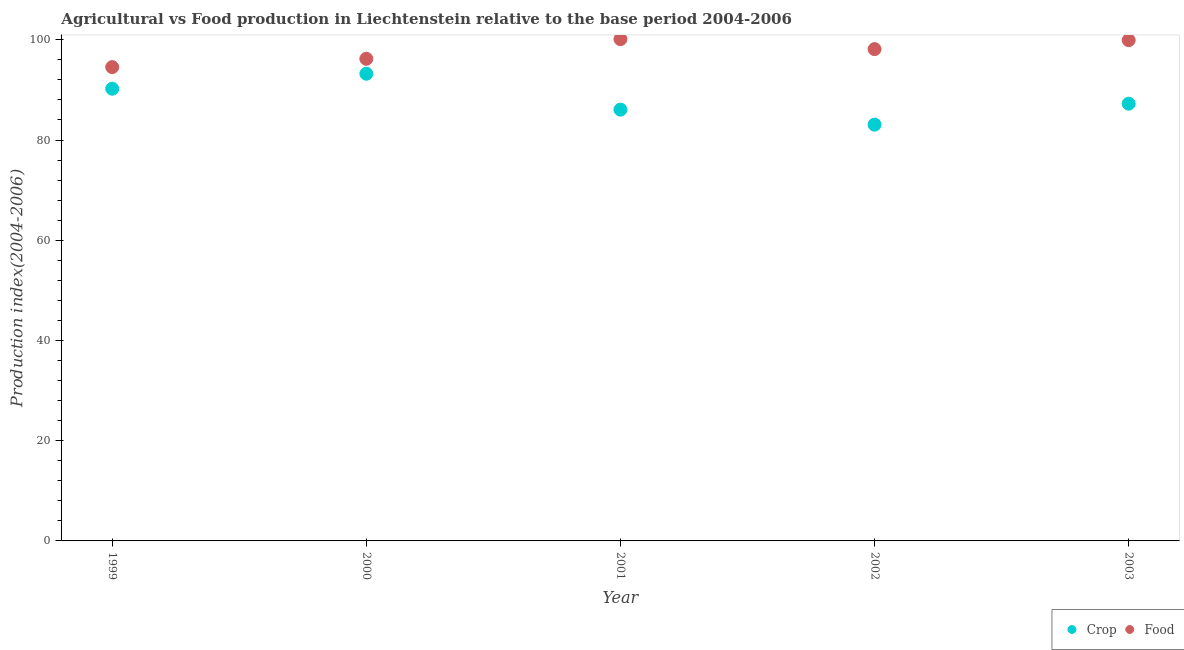Is the number of dotlines equal to the number of legend labels?
Your response must be concise. Yes. What is the food production index in 2000?
Give a very brief answer. 96.21. Across all years, what is the maximum food production index?
Provide a short and direct response. 100.13. Across all years, what is the minimum crop production index?
Offer a terse response. 83.07. In which year was the food production index minimum?
Provide a short and direct response. 1999. What is the total food production index in the graph?
Give a very brief answer. 488.96. What is the difference between the crop production index in 2001 and that in 2003?
Ensure brevity in your answer.  -1.19. What is the difference between the crop production index in 2003 and the food production index in 2002?
Offer a very short reply. -10.89. What is the average food production index per year?
Give a very brief answer. 97.79. In the year 2003, what is the difference between the crop production index and food production index?
Keep it short and to the point. -12.68. In how many years, is the food production index greater than 24?
Give a very brief answer. 5. What is the ratio of the food production index in 1999 to that in 2002?
Provide a succinct answer. 0.96. Is the difference between the crop production index in 2001 and 2003 greater than the difference between the food production index in 2001 and 2003?
Provide a succinct answer. No. What is the difference between the highest and the second highest crop production index?
Make the answer very short. 2.99. What is the difference between the highest and the lowest food production index?
Your answer should be compact. 5.58. Does the crop production index monotonically increase over the years?
Offer a terse response. No. Is the food production index strictly greater than the crop production index over the years?
Provide a short and direct response. Yes. Does the graph contain any zero values?
Your answer should be very brief. No. Does the graph contain grids?
Your answer should be compact. No. Where does the legend appear in the graph?
Your answer should be compact. Bottom right. What is the title of the graph?
Your answer should be compact. Agricultural vs Food production in Liechtenstein relative to the base period 2004-2006. Does "Tetanus" appear as one of the legend labels in the graph?
Offer a terse response. No. What is the label or title of the X-axis?
Offer a terse response. Year. What is the label or title of the Y-axis?
Make the answer very short. Production index(2004-2006). What is the Production index(2004-2006) in Crop in 1999?
Your answer should be compact. 90.24. What is the Production index(2004-2006) in Food in 1999?
Give a very brief answer. 94.55. What is the Production index(2004-2006) in Crop in 2000?
Provide a succinct answer. 93.23. What is the Production index(2004-2006) in Food in 2000?
Make the answer very short. 96.21. What is the Production index(2004-2006) in Crop in 2001?
Give a very brief answer. 86.06. What is the Production index(2004-2006) of Food in 2001?
Your answer should be very brief. 100.13. What is the Production index(2004-2006) in Crop in 2002?
Provide a succinct answer. 83.07. What is the Production index(2004-2006) of Food in 2002?
Make the answer very short. 98.14. What is the Production index(2004-2006) in Crop in 2003?
Your answer should be compact. 87.25. What is the Production index(2004-2006) in Food in 2003?
Give a very brief answer. 99.93. Across all years, what is the maximum Production index(2004-2006) of Crop?
Make the answer very short. 93.23. Across all years, what is the maximum Production index(2004-2006) in Food?
Provide a short and direct response. 100.13. Across all years, what is the minimum Production index(2004-2006) in Crop?
Keep it short and to the point. 83.07. Across all years, what is the minimum Production index(2004-2006) of Food?
Make the answer very short. 94.55. What is the total Production index(2004-2006) in Crop in the graph?
Offer a terse response. 439.85. What is the total Production index(2004-2006) in Food in the graph?
Offer a terse response. 488.96. What is the difference between the Production index(2004-2006) in Crop in 1999 and that in 2000?
Keep it short and to the point. -2.99. What is the difference between the Production index(2004-2006) in Food in 1999 and that in 2000?
Offer a very short reply. -1.66. What is the difference between the Production index(2004-2006) in Crop in 1999 and that in 2001?
Give a very brief answer. 4.18. What is the difference between the Production index(2004-2006) in Food in 1999 and that in 2001?
Offer a terse response. -5.58. What is the difference between the Production index(2004-2006) of Crop in 1999 and that in 2002?
Provide a short and direct response. 7.17. What is the difference between the Production index(2004-2006) in Food in 1999 and that in 2002?
Keep it short and to the point. -3.59. What is the difference between the Production index(2004-2006) of Crop in 1999 and that in 2003?
Your answer should be compact. 2.99. What is the difference between the Production index(2004-2006) of Food in 1999 and that in 2003?
Make the answer very short. -5.38. What is the difference between the Production index(2004-2006) of Crop in 2000 and that in 2001?
Make the answer very short. 7.17. What is the difference between the Production index(2004-2006) in Food in 2000 and that in 2001?
Your answer should be very brief. -3.92. What is the difference between the Production index(2004-2006) of Crop in 2000 and that in 2002?
Make the answer very short. 10.16. What is the difference between the Production index(2004-2006) in Food in 2000 and that in 2002?
Your answer should be very brief. -1.93. What is the difference between the Production index(2004-2006) in Crop in 2000 and that in 2003?
Provide a succinct answer. 5.98. What is the difference between the Production index(2004-2006) in Food in 2000 and that in 2003?
Provide a succinct answer. -3.72. What is the difference between the Production index(2004-2006) of Crop in 2001 and that in 2002?
Your answer should be compact. 2.99. What is the difference between the Production index(2004-2006) of Food in 2001 and that in 2002?
Provide a succinct answer. 1.99. What is the difference between the Production index(2004-2006) in Crop in 2001 and that in 2003?
Provide a short and direct response. -1.19. What is the difference between the Production index(2004-2006) of Crop in 2002 and that in 2003?
Give a very brief answer. -4.18. What is the difference between the Production index(2004-2006) of Food in 2002 and that in 2003?
Provide a succinct answer. -1.79. What is the difference between the Production index(2004-2006) in Crop in 1999 and the Production index(2004-2006) in Food in 2000?
Give a very brief answer. -5.97. What is the difference between the Production index(2004-2006) in Crop in 1999 and the Production index(2004-2006) in Food in 2001?
Provide a short and direct response. -9.89. What is the difference between the Production index(2004-2006) of Crop in 1999 and the Production index(2004-2006) of Food in 2003?
Offer a very short reply. -9.69. What is the difference between the Production index(2004-2006) in Crop in 2000 and the Production index(2004-2006) in Food in 2001?
Your answer should be compact. -6.9. What is the difference between the Production index(2004-2006) of Crop in 2000 and the Production index(2004-2006) of Food in 2002?
Keep it short and to the point. -4.91. What is the difference between the Production index(2004-2006) in Crop in 2000 and the Production index(2004-2006) in Food in 2003?
Provide a succinct answer. -6.7. What is the difference between the Production index(2004-2006) in Crop in 2001 and the Production index(2004-2006) in Food in 2002?
Make the answer very short. -12.08. What is the difference between the Production index(2004-2006) of Crop in 2001 and the Production index(2004-2006) of Food in 2003?
Your response must be concise. -13.87. What is the difference between the Production index(2004-2006) in Crop in 2002 and the Production index(2004-2006) in Food in 2003?
Ensure brevity in your answer.  -16.86. What is the average Production index(2004-2006) in Crop per year?
Your answer should be compact. 87.97. What is the average Production index(2004-2006) in Food per year?
Your answer should be compact. 97.79. In the year 1999, what is the difference between the Production index(2004-2006) in Crop and Production index(2004-2006) in Food?
Offer a very short reply. -4.31. In the year 2000, what is the difference between the Production index(2004-2006) of Crop and Production index(2004-2006) of Food?
Offer a terse response. -2.98. In the year 2001, what is the difference between the Production index(2004-2006) in Crop and Production index(2004-2006) in Food?
Your response must be concise. -14.07. In the year 2002, what is the difference between the Production index(2004-2006) in Crop and Production index(2004-2006) in Food?
Offer a terse response. -15.07. In the year 2003, what is the difference between the Production index(2004-2006) in Crop and Production index(2004-2006) in Food?
Offer a very short reply. -12.68. What is the ratio of the Production index(2004-2006) of Crop in 1999 to that in 2000?
Provide a succinct answer. 0.97. What is the ratio of the Production index(2004-2006) of Food in 1999 to that in 2000?
Your response must be concise. 0.98. What is the ratio of the Production index(2004-2006) of Crop in 1999 to that in 2001?
Keep it short and to the point. 1.05. What is the ratio of the Production index(2004-2006) in Food in 1999 to that in 2001?
Provide a short and direct response. 0.94. What is the ratio of the Production index(2004-2006) of Crop in 1999 to that in 2002?
Your answer should be very brief. 1.09. What is the ratio of the Production index(2004-2006) in Food in 1999 to that in 2002?
Keep it short and to the point. 0.96. What is the ratio of the Production index(2004-2006) of Crop in 1999 to that in 2003?
Provide a succinct answer. 1.03. What is the ratio of the Production index(2004-2006) in Food in 1999 to that in 2003?
Ensure brevity in your answer.  0.95. What is the ratio of the Production index(2004-2006) of Food in 2000 to that in 2001?
Your answer should be very brief. 0.96. What is the ratio of the Production index(2004-2006) in Crop in 2000 to that in 2002?
Keep it short and to the point. 1.12. What is the ratio of the Production index(2004-2006) of Food in 2000 to that in 2002?
Provide a succinct answer. 0.98. What is the ratio of the Production index(2004-2006) of Crop in 2000 to that in 2003?
Make the answer very short. 1.07. What is the ratio of the Production index(2004-2006) of Food in 2000 to that in 2003?
Offer a terse response. 0.96. What is the ratio of the Production index(2004-2006) of Crop in 2001 to that in 2002?
Your answer should be compact. 1.04. What is the ratio of the Production index(2004-2006) in Food in 2001 to that in 2002?
Offer a very short reply. 1.02. What is the ratio of the Production index(2004-2006) in Crop in 2001 to that in 2003?
Provide a succinct answer. 0.99. What is the ratio of the Production index(2004-2006) in Crop in 2002 to that in 2003?
Keep it short and to the point. 0.95. What is the ratio of the Production index(2004-2006) of Food in 2002 to that in 2003?
Keep it short and to the point. 0.98. What is the difference between the highest and the second highest Production index(2004-2006) of Crop?
Your response must be concise. 2.99. What is the difference between the highest and the lowest Production index(2004-2006) in Crop?
Your answer should be compact. 10.16. What is the difference between the highest and the lowest Production index(2004-2006) in Food?
Make the answer very short. 5.58. 